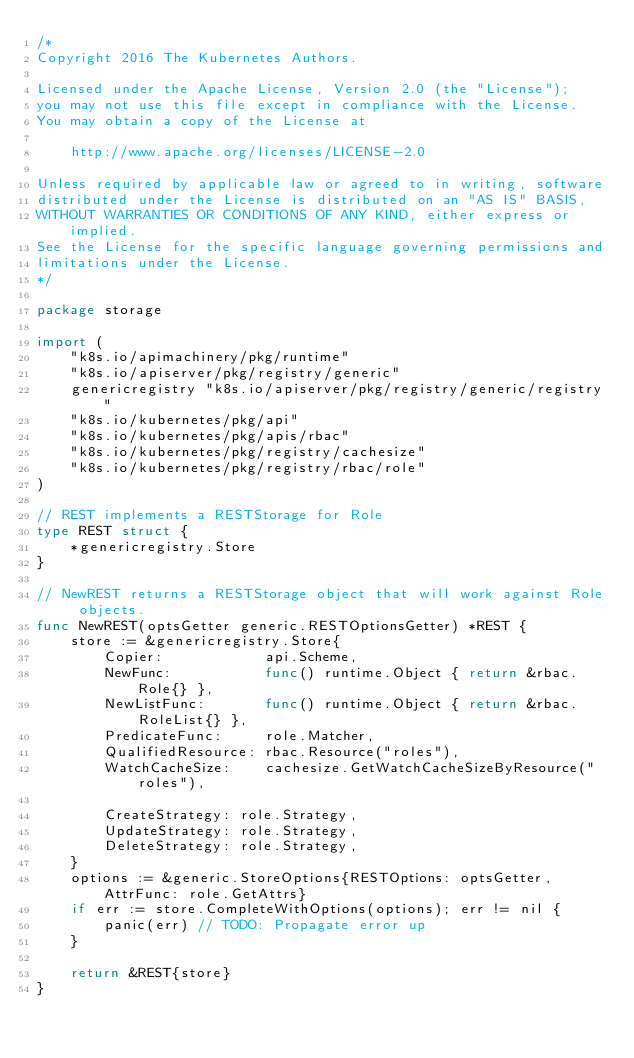Convert code to text. <code><loc_0><loc_0><loc_500><loc_500><_Go_>/*
Copyright 2016 The Kubernetes Authors.

Licensed under the Apache License, Version 2.0 (the "License");
you may not use this file except in compliance with the License.
You may obtain a copy of the License at

    http://www.apache.org/licenses/LICENSE-2.0

Unless required by applicable law or agreed to in writing, software
distributed under the License is distributed on an "AS IS" BASIS,
WITHOUT WARRANTIES OR CONDITIONS OF ANY KIND, either express or implied.
See the License for the specific language governing permissions and
limitations under the License.
*/

package storage

import (
	"k8s.io/apimachinery/pkg/runtime"
	"k8s.io/apiserver/pkg/registry/generic"
	genericregistry "k8s.io/apiserver/pkg/registry/generic/registry"
	"k8s.io/kubernetes/pkg/api"
	"k8s.io/kubernetes/pkg/apis/rbac"
	"k8s.io/kubernetes/pkg/registry/cachesize"
	"k8s.io/kubernetes/pkg/registry/rbac/role"
)

// REST implements a RESTStorage for Role
type REST struct {
	*genericregistry.Store
}

// NewREST returns a RESTStorage object that will work against Role objects.
func NewREST(optsGetter generic.RESTOptionsGetter) *REST {
	store := &genericregistry.Store{
		Copier:            api.Scheme,
		NewFunc:           func() runtime.Object { return &rbac.Role{} },
		NewListFunc:       func() runtime.Object { return &rbac.RoleList{} },
		PredicateFunc:     role.Matcher,
		QualifiedResource: rbac.Resource("roles"),
		WatchCacheSize:    cachesize.GetWatchCacheSizeByResource("roles"),

		CreateStrategy: role.Strategy,
		UpdateStrategy: role.Strategy,
		DeleteStrategy: role.Strategy,
	}
	options := &generic.StoreOptions{RESTOptions: optsGetter, AttrFunc: role.GetAttrs}
	if err := store.CompleteWithOptions(options); err != nil {
		panic(err) // TODO: Propagate error up
	}

	return &REST{store}
}
</code> 